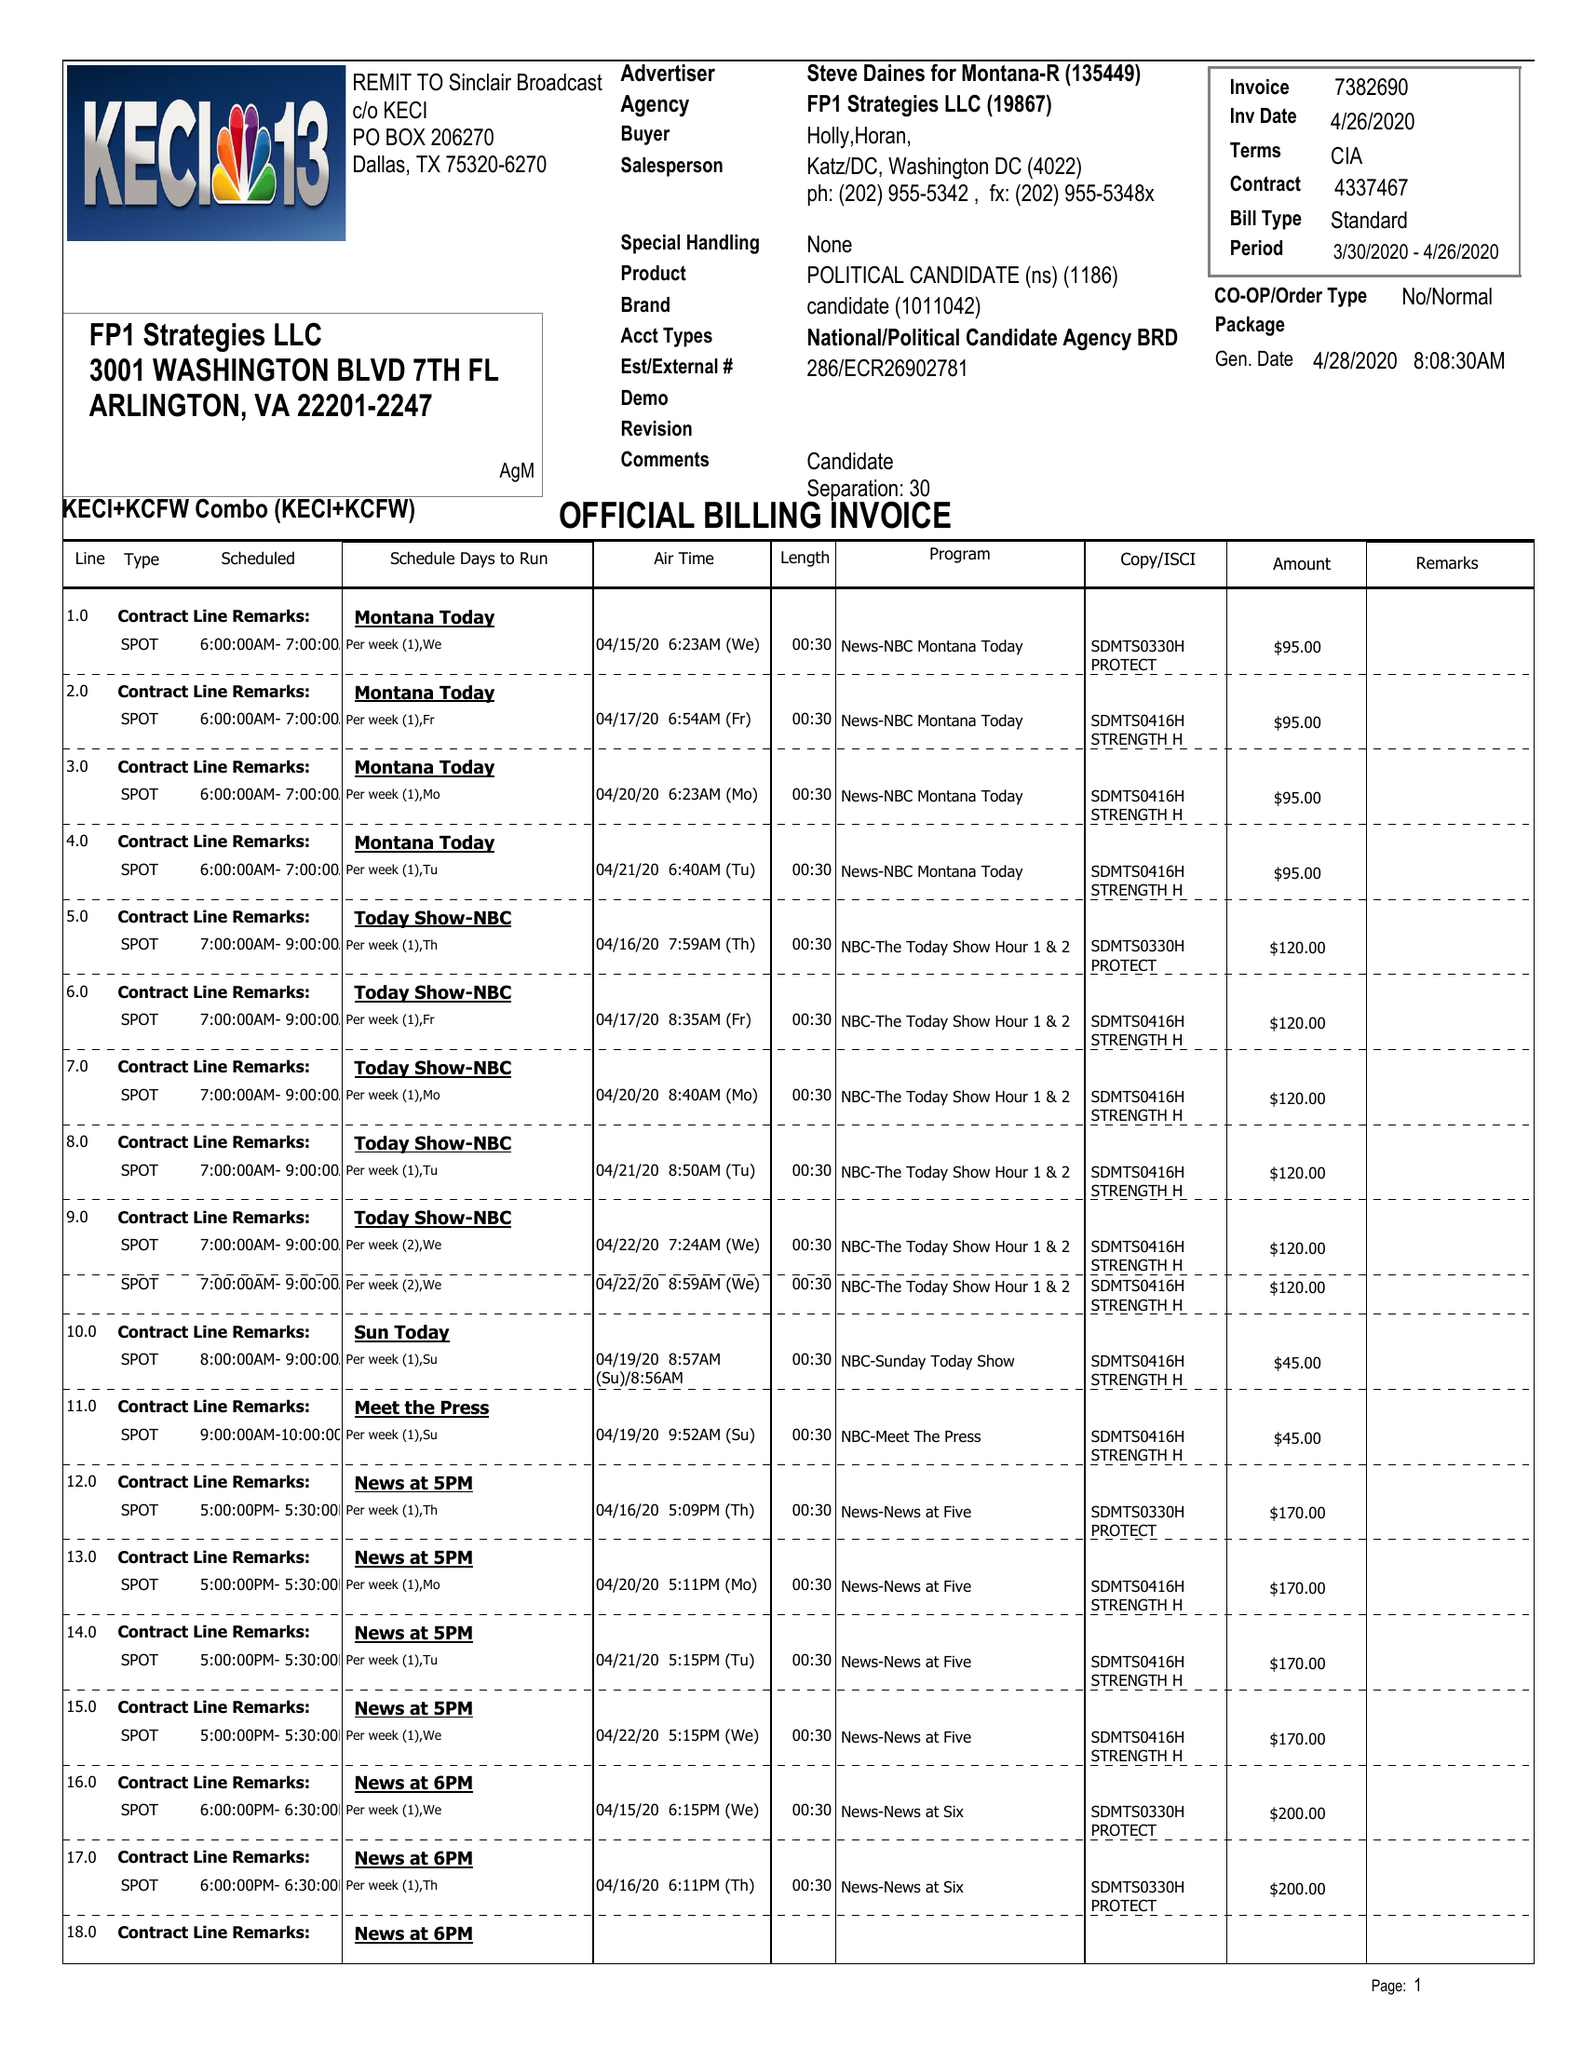What is the value for the gross_amount?
Answer the question using a single word or phrase. 6170.00 